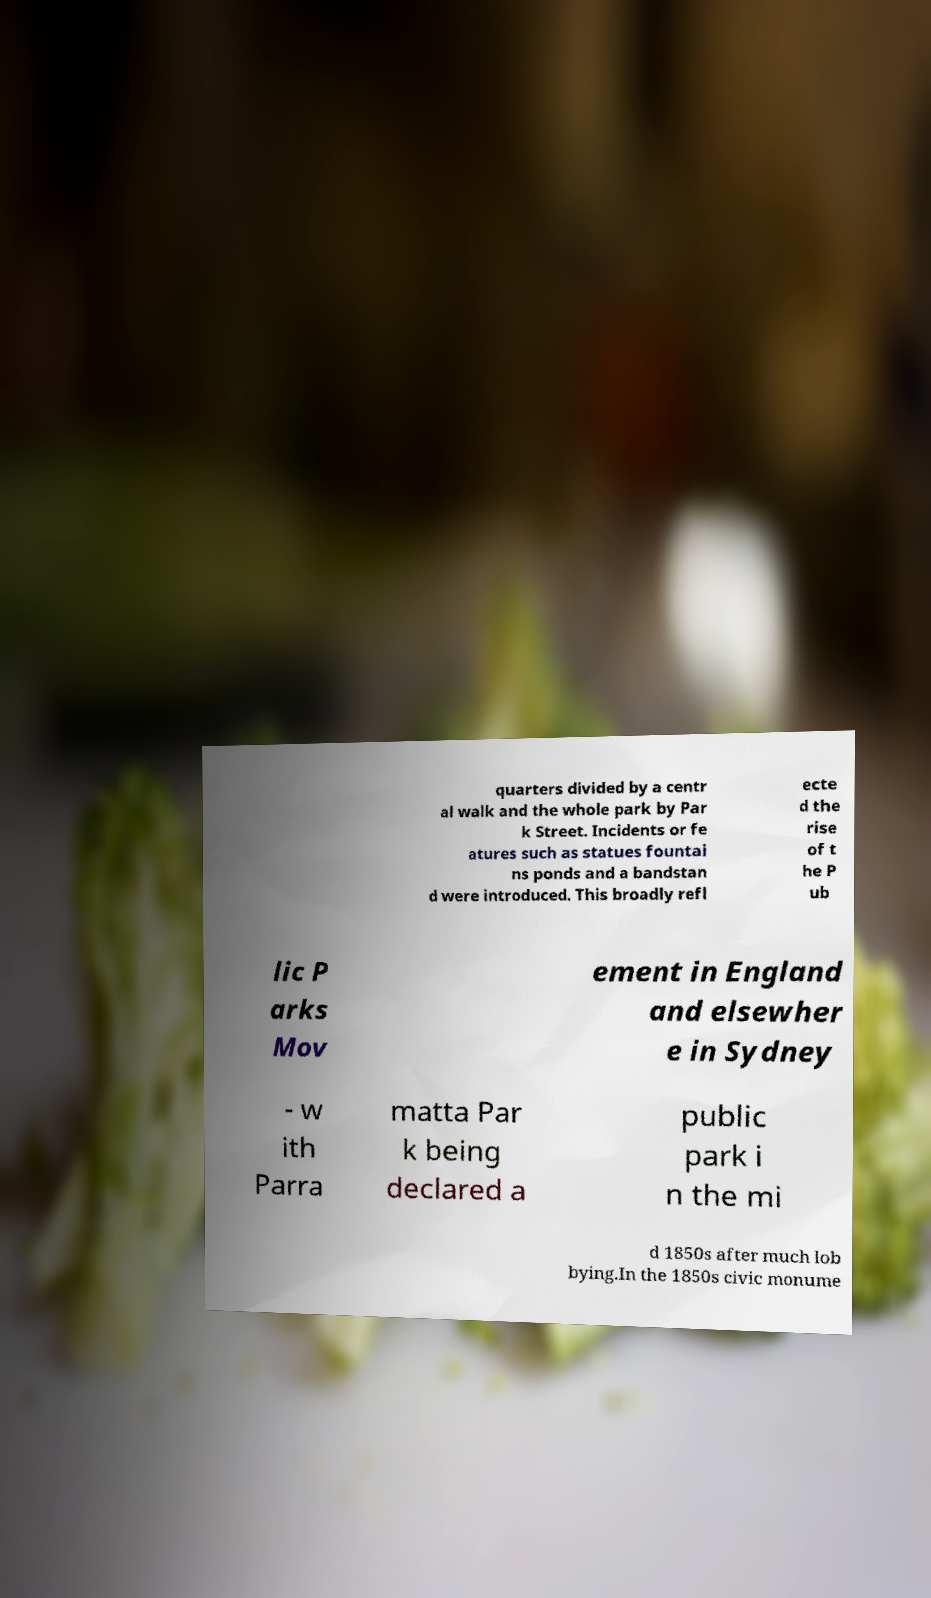There's text embedded in this image that I need extracted. Can you transcribe it verbatim? quarters divided by a centr al walk and the whole park by Par k Street. Incidents or fe atures such as statues fountai ns ponds and a bandstan d were introduced. This broadly refl ecte d the rise of t he P ub lic P arks Mov ement in England and elsewher e in Sydney - w ith Parra matta Par k being declared a public park i n the mi d 1850s after much lob bying.In the 1850s civic monume 